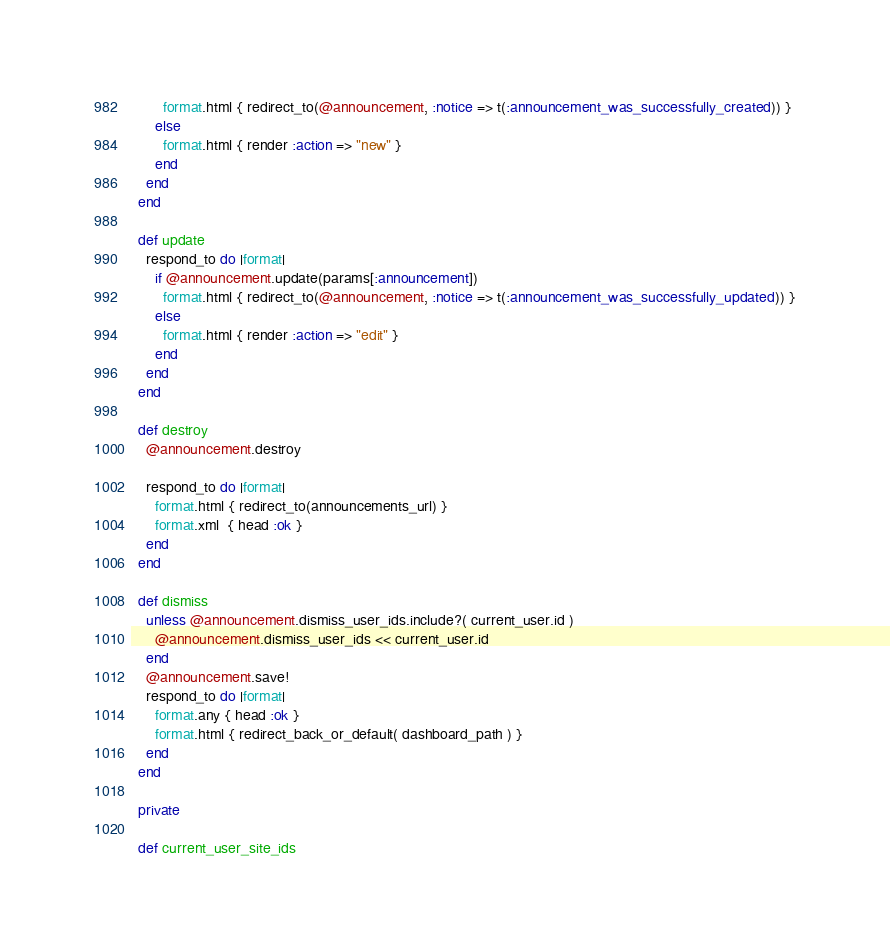<code> <loc_0><loc_0><loc_500><loc_500><_Ruby_>        format.html { redirect_to(@announcement, :notice => t(:announcement_was_successfully_created)) }
      else
        format.html { render :action => "new" }
      end
    end
  end

  def update
    respond_to do |format|
      if @announcement.update(params[:announcement])
        format.html { redirect_to(@announcement, :notice => t(:announcement_was_successfully_updated)) }
      else
        format.html { render :action => "edit" }
      end
    end
  end

  def destroy
    @announcement.destroy

    respond_to do |format|
      format.html { redirect_to(announcements_url) }
      format.xml  { head :ok }
    end
  end

  def dismiss
    unless @announcement.dismiss_user_ids.include?( current_user.id )
      @announcement.dismiss_user_ids << current_user.id
    end
    @announcement.save!
    respond_to do |format|
      format.any { head :ok }
      format.html { redirect_back_or_default( dashboard_path ) }
    end
  end

  private

  def current_user_site_ids</code> 